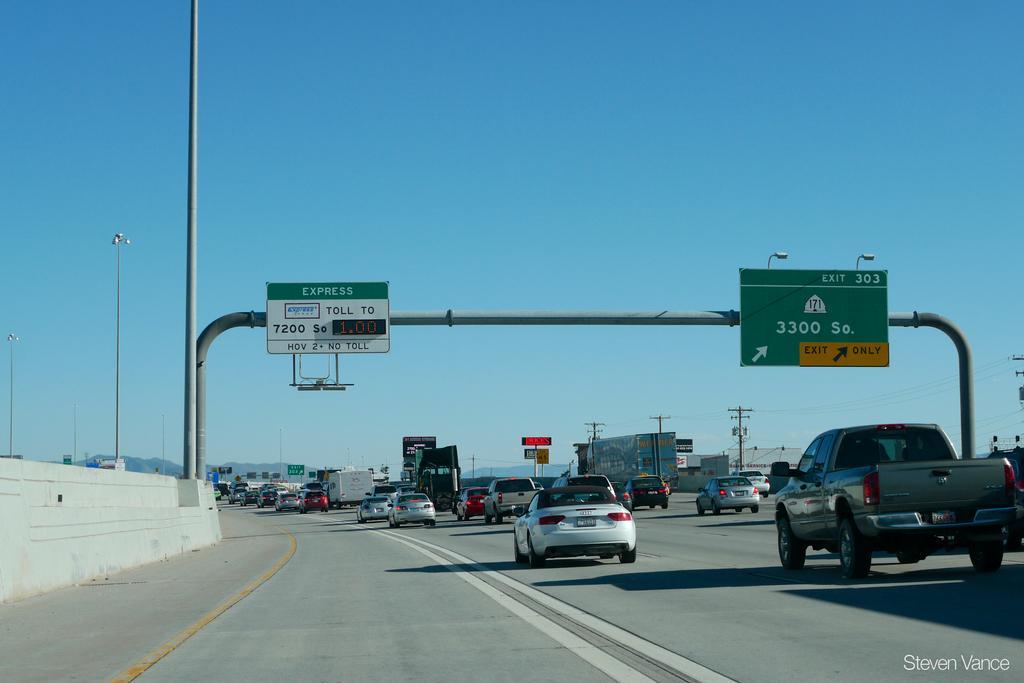Could you give a brief overview of what you see in this image? In the picture we can see a road with some cars running on it and beside the road we can see a white color wall with some poles and some boards with kilometer readings on it and in the background we can see a sky which is blue in color. 